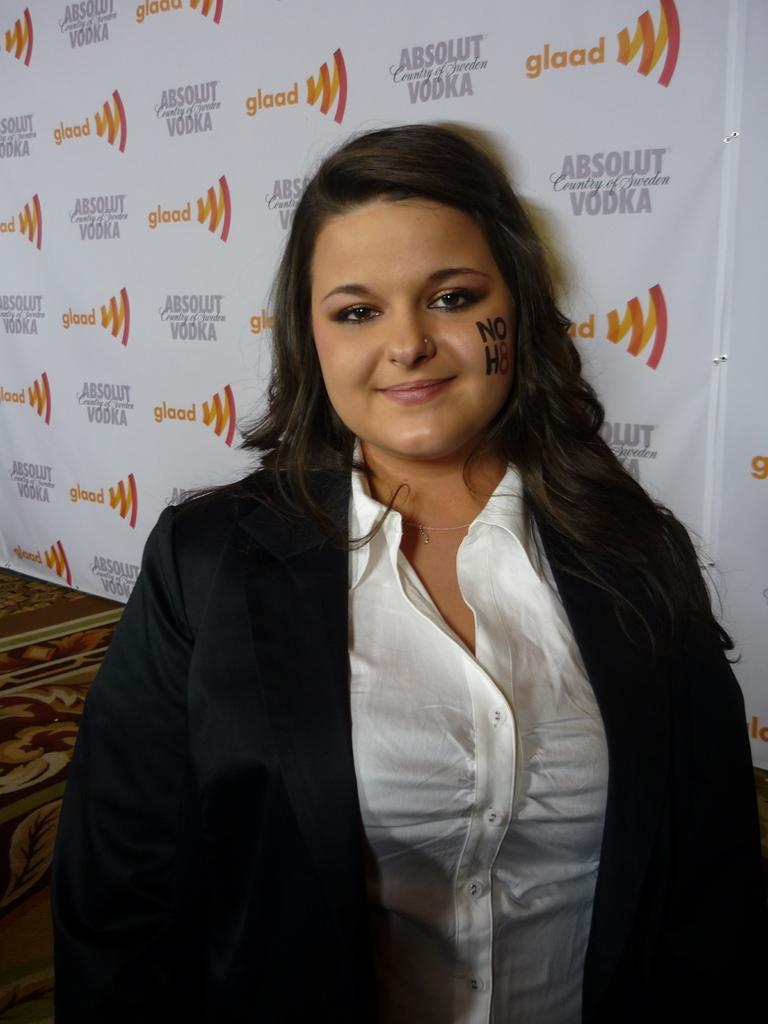Please provide a concise description of this image. There is one women standing at the bottom of this image is wearing a black color blazer. There is a wall poster in the background. 